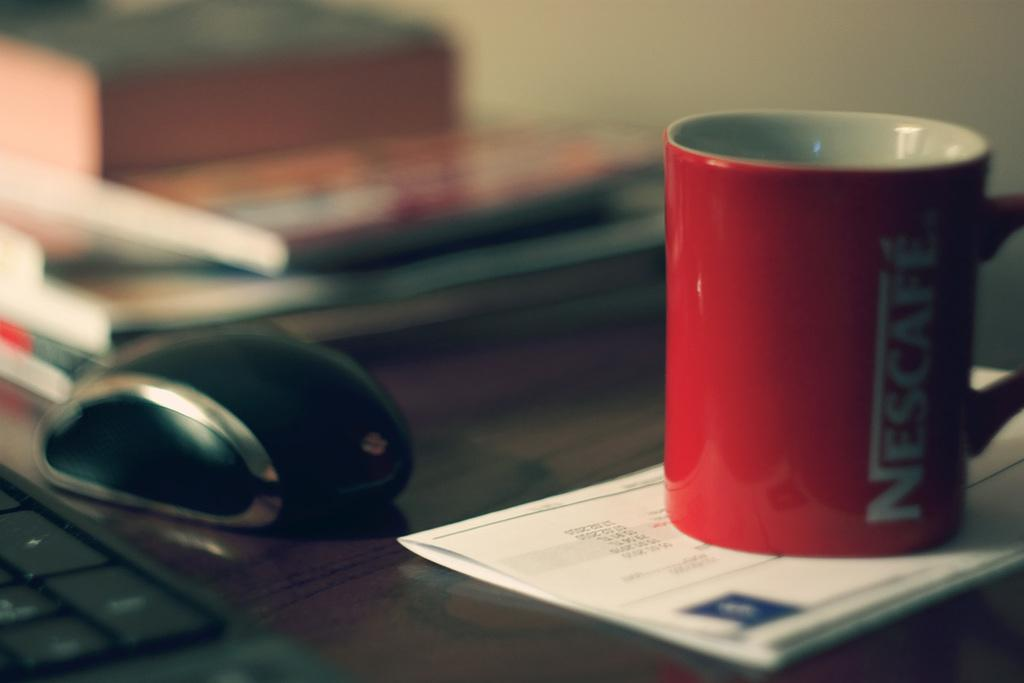<image>
Offer a succinct explanation of the picture presented. Red cup of Nescafe next to a computer mouse on a table. 